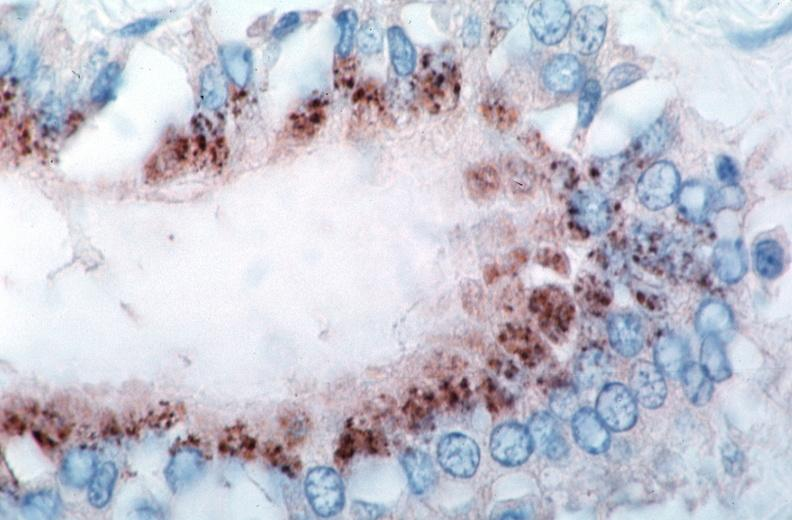what spotted fever , immunoperoxidase staining vessels for rickettsia rickettsii?
Answer the question using a single word or phrase. Vasculitis rocky mountain 